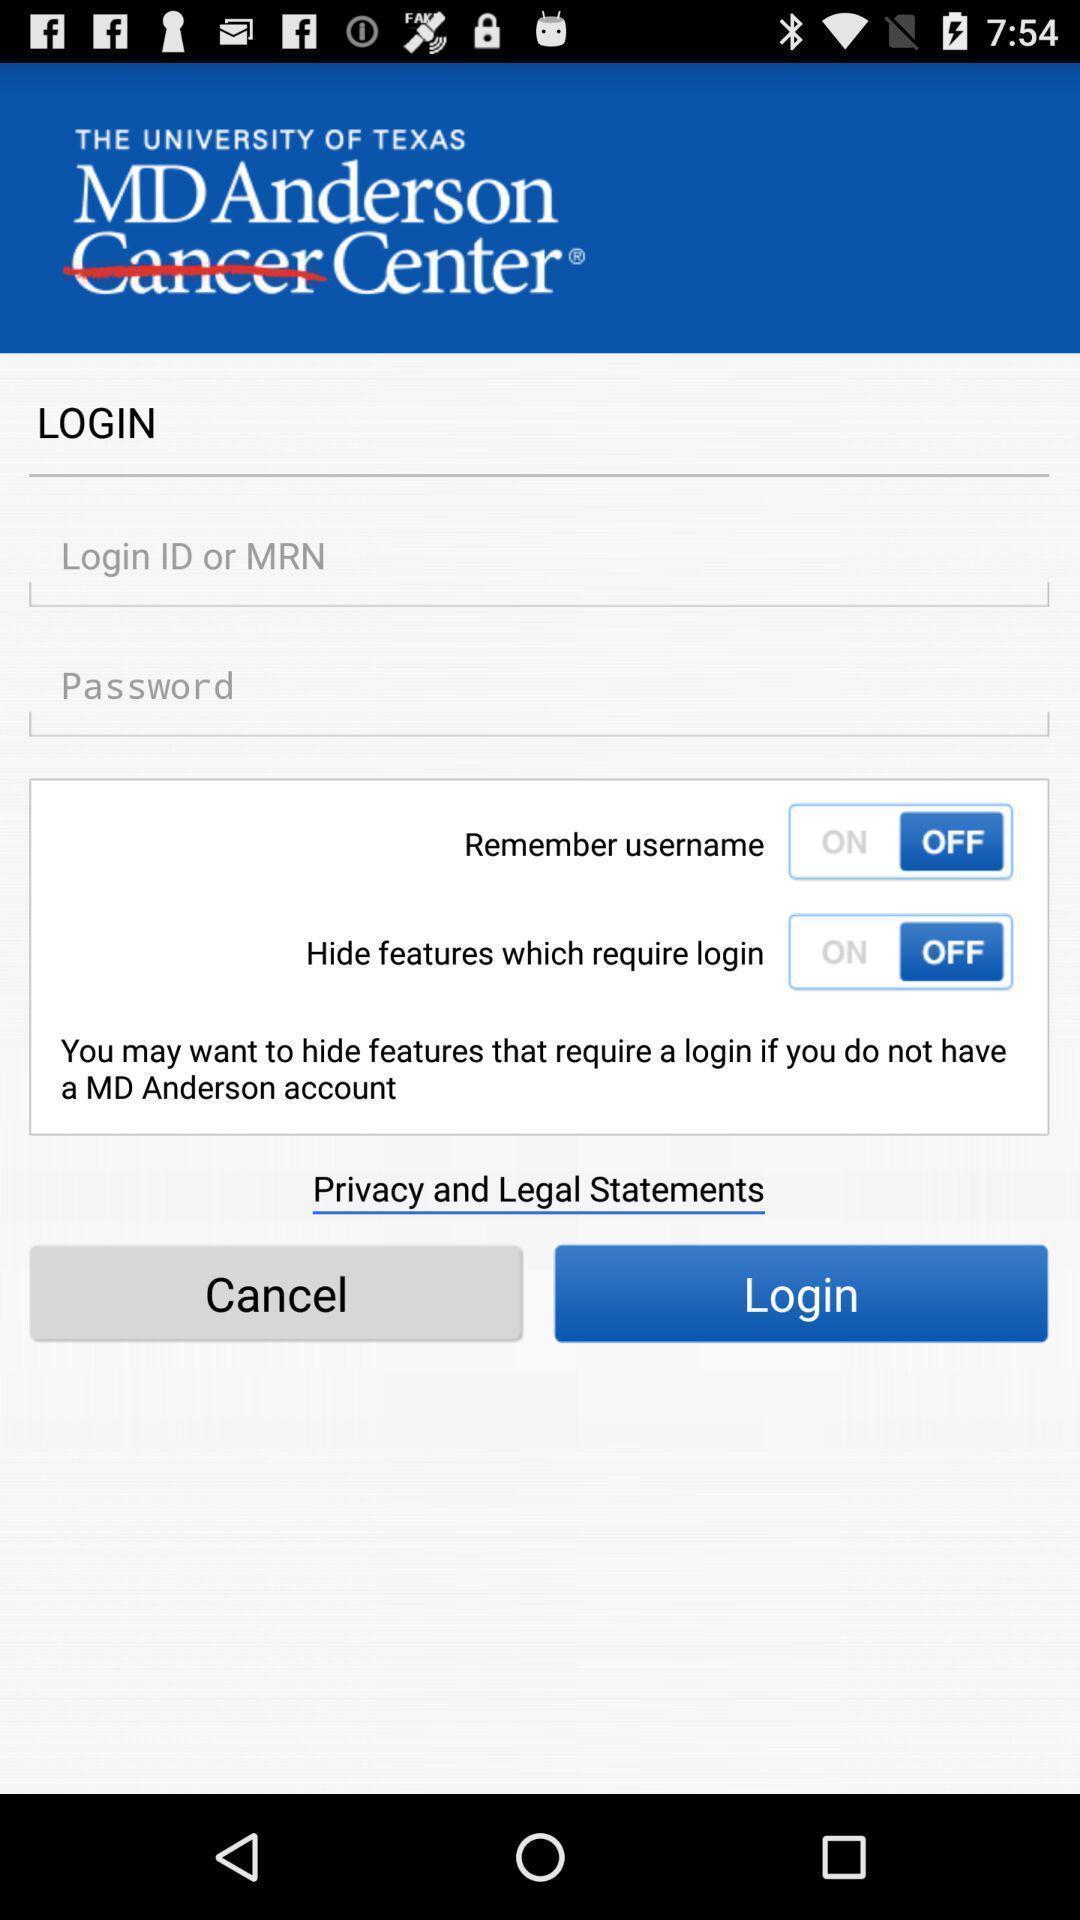Tell me what you see in this picture. Login page. 